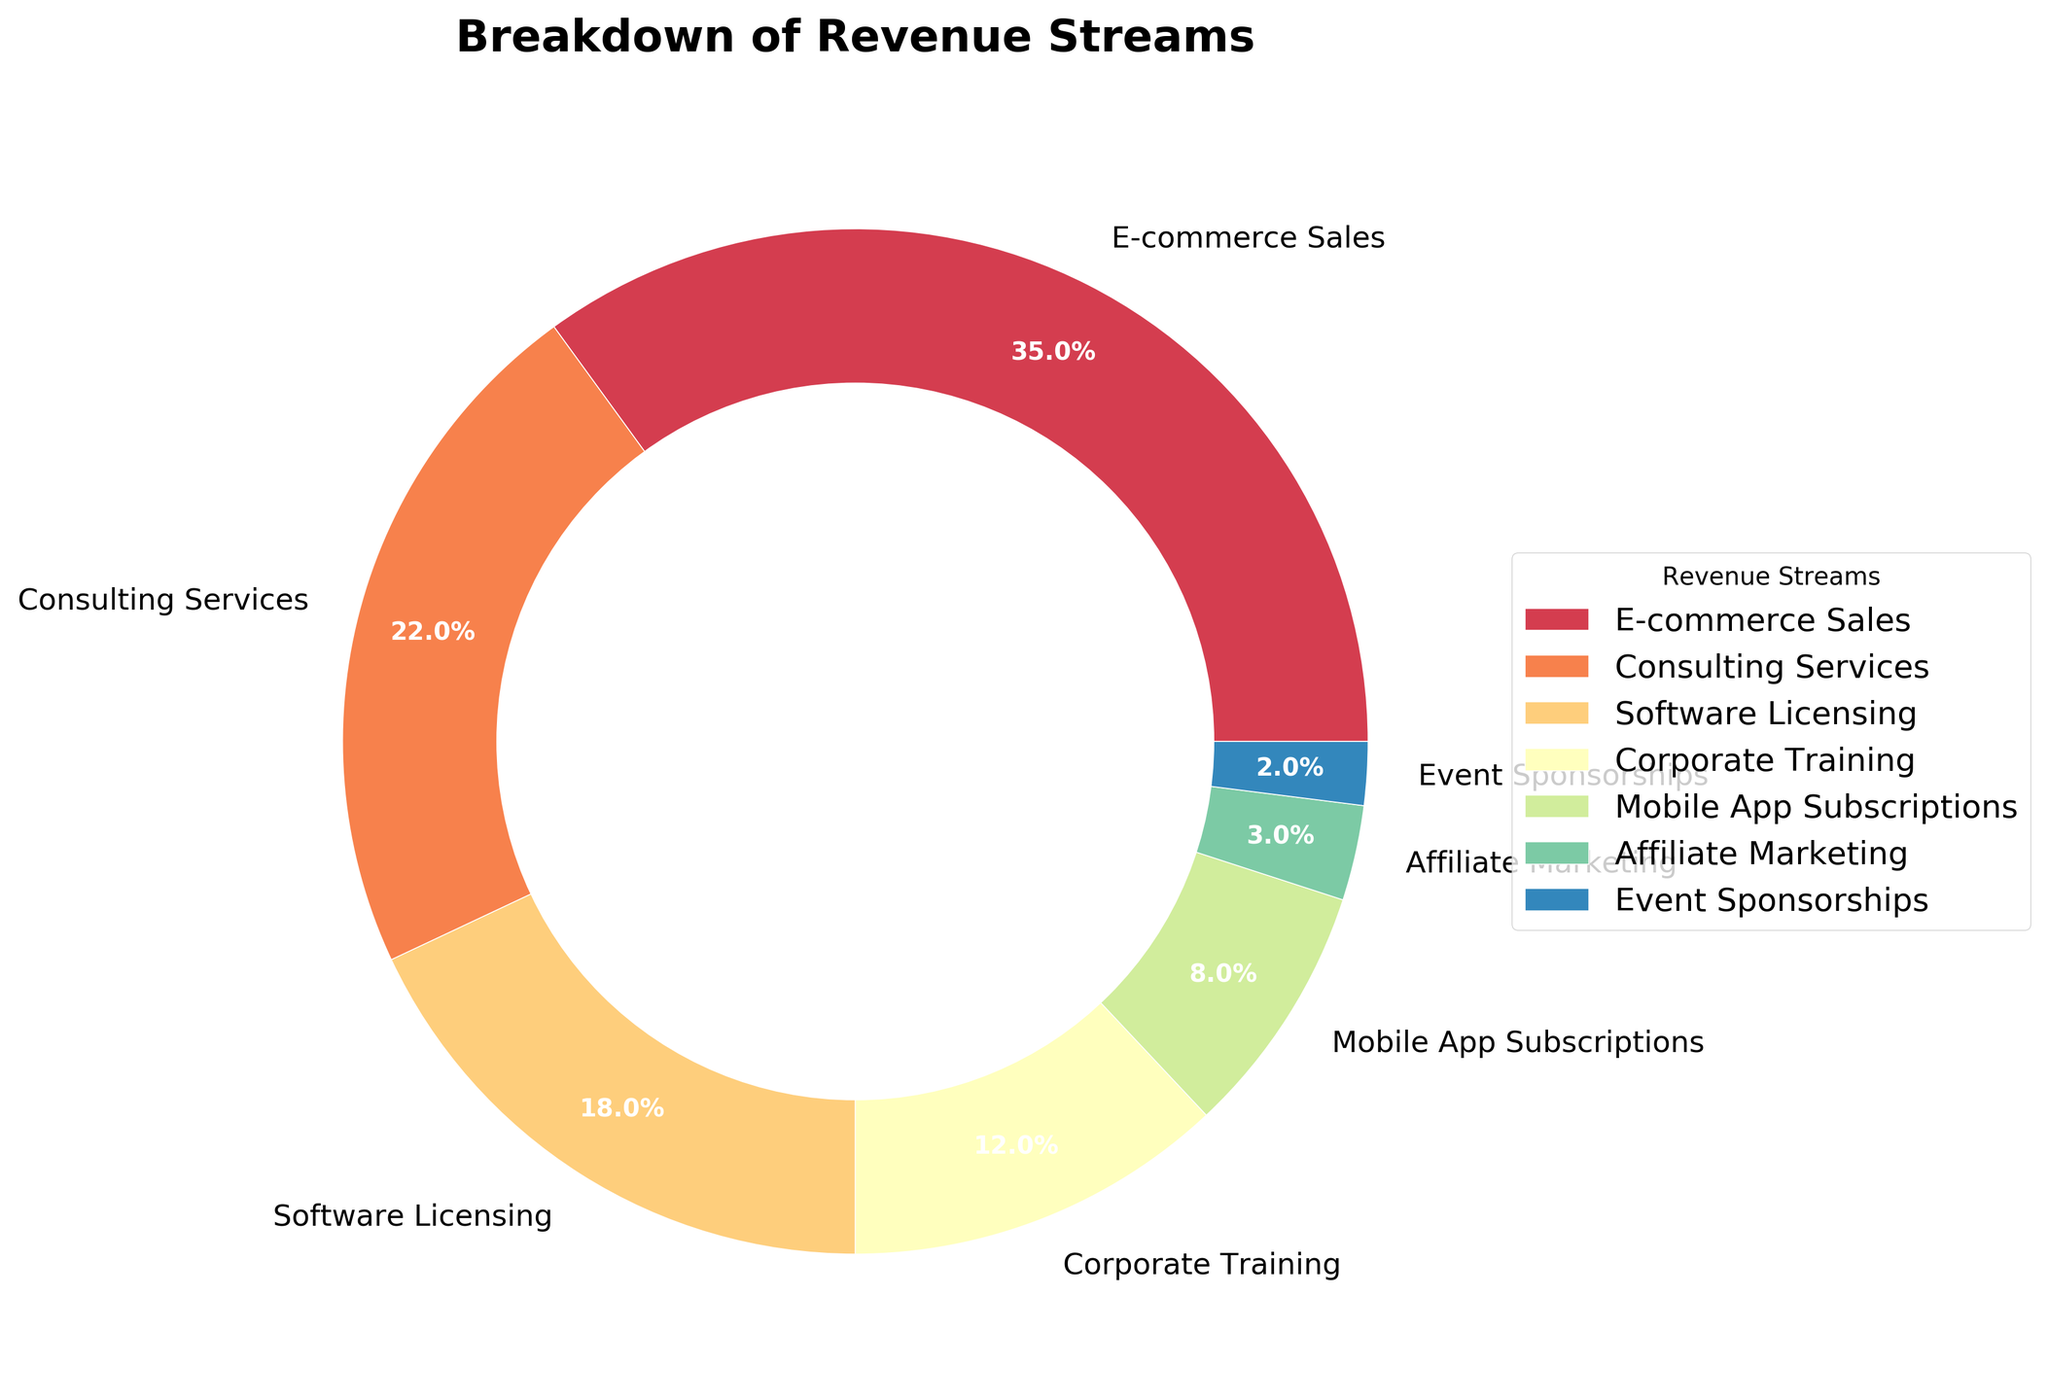What's the largest revenue stream? The pie chart shows different segments representing the revenue streams. The largest segment is for E-commerce Sales, indicated by the largest percentage (35%).
Answer: E-commerce Sales Which revenue stream contributes the smallest percentage? The smallest segment in the pie chart represents Event Sponsorships with 2%.
Answer: Event Sponsorships What is the combined percentage of Software Licensing and Mobile App Subscriptions? Software Licensing accounts for 18% and Mobile App Subscriptions for 8%. Adding these two percentages, 18% + 8% = 26%.
Answer: 26% How does the percentage of Consulting Services compare to Corporate Training? Consulting Services have a percentage of 22%, whereas Corporate Training has a percentage of 12%. Consulting Services contribute 10% more than Corporate Training.
Answer: 10% more What revenue streams together make up more than half of the total revenue? The segments for E-commerce Sales (35%) and Consulting Services (22%) together make up 35% + 22% = 57%, which is more than half of the total revenue.
Answer: E-commerce Sales and Consulting Services What is the color of the segment representing Affiliate Marketing? The pie chart uses different colors for different segments. The segment for Affiliate Marketing is positioned and labeled in the plot, and it typically has a specific color that can be identified.
Answer: [Color based on the plot] Which revenue stream has the second-largest contribution? The pie chart shows the second-largest segment has a percentage of 22%, which is Consulting Services.
Answer: Consulting Services 